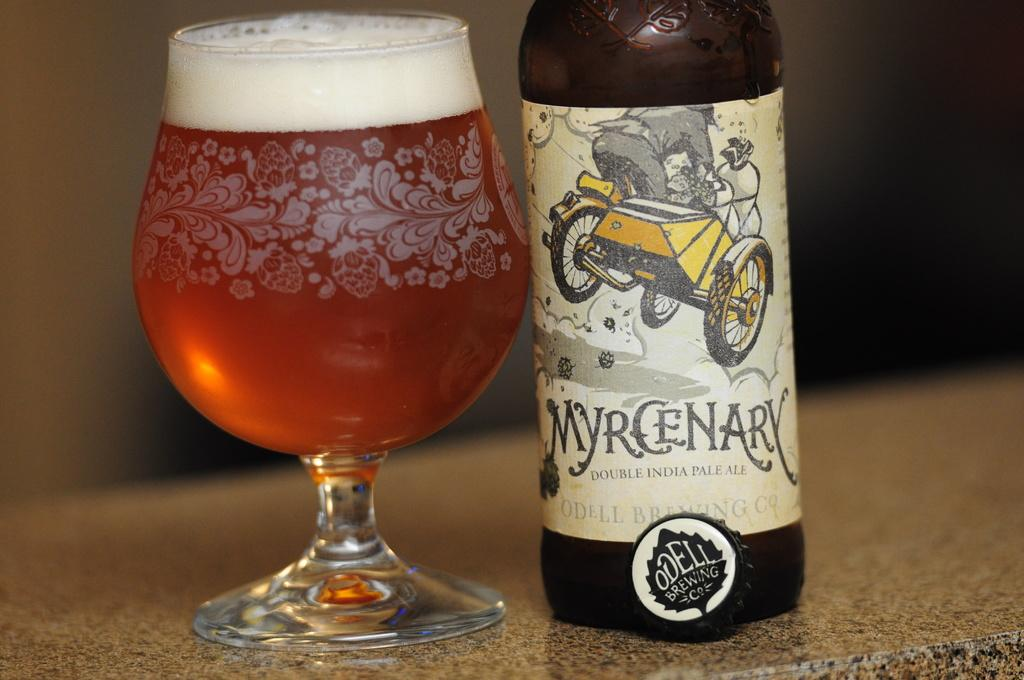<image>
Offer a succinct explanation of the picture presented. A bottle of Double India pale ale is called Myrcenary. 